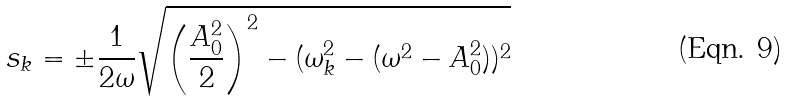<formula> <loc_0><loc_0><loc_500><loc_500>s _ { k } = \pm { \frac { 1 } { 2 \omega } } \sqrt { \left ( { \frac { A _ { 0 } ^ { 2 } } { 2 } } \right ) ^ { 2 } - ( \omega _ { k } ^ { 2 } - ( \omega ^ { 2 } - A _ { 0 } ^ { 2 } ) ) ^ { 2 } }</formula> 